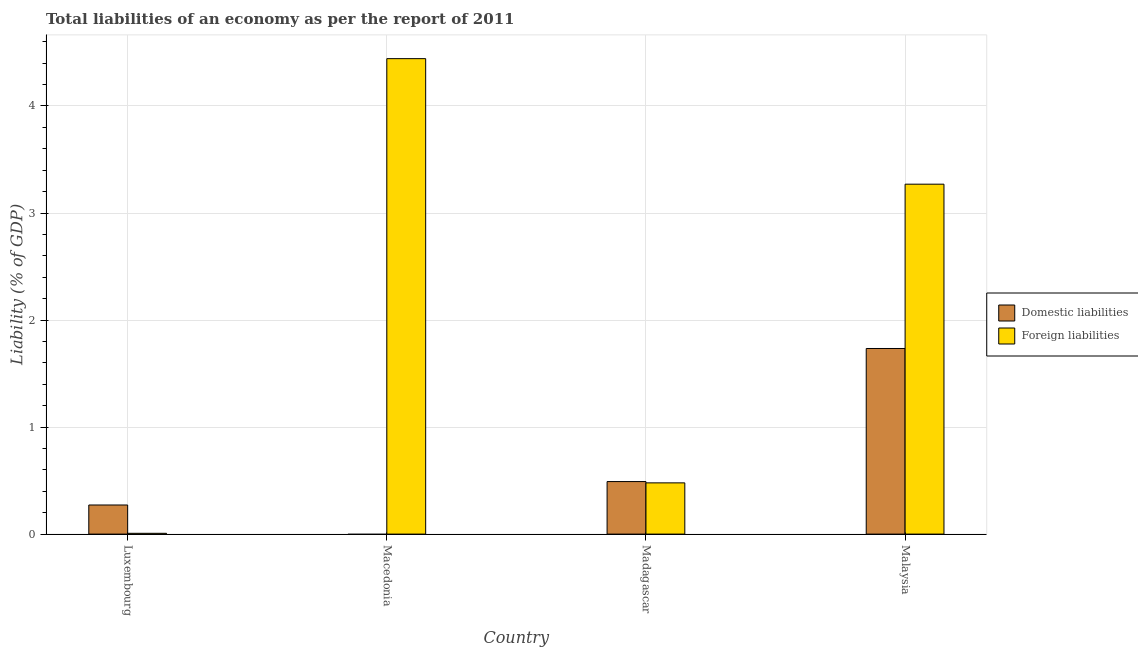How many different coloured bars are there?
Offer a very short reply. 2. Are the number of bars per tick equal to the number of legend labels?
Ensure brevity in your answer.  No. Are the number of bars on each tick of the X-axis equal?
Keep it short and to the point. No. What is the label of the 2nd group of bars from the left?
Make the answer very short. Macedonia. What is the incurrence of foreign liabilities in Macedonia?
Provide a succinct answer. 4.44. Across all countries, what is the maximum incurrence of foreign liabilities?
Provide a succinct answer. 4.44. Across all countries, what is the minimum incurrence of foreign liabilities?
Give a very brief answer. 0.01. In which country was the incurrence of foreign liabilities maximum?
Offer a very short reply. Macedonia. What is the total incurrence of foreign liabilities in the graph?
Your answer should be very brief. 8.2. What is the difference between the incurrence of foreign liabilities in Macedonia and that in Madagascar?
Provide a succinct answer. 3.96. What is the difference between the incurrence of foreign liabilities in Malaysia and the incurrence of domestic liabilities in Luxembourg?
Your answer should be compact. 3. What is the average incurrence of foreign liabilities per country?
Keep it short and to the point. 2.05. What is the difference between the incurrence of domestic liabilities and incurrence of foreign liabilities in Luxembourg?
Make the answer very short. 0.26. What is the ratio of the incurrence of domestic liabilities in Madagascar to that in Malaysia?
Provide a succinct answer. 0.28. Is the incurrence of foreign liabilities in Macedonia less than that in Malaysia?
Make the answer very short. No. Is the difference between the incurrence of foreign liabilities in Luxembourg and Madagascar greater than the difference between the incurrence of domestic liabilities in Luxembourg and Madagascar?
Give a very brief answer. No. What is the difference between the highest and the second highest incurrence of foreign liabilities?
Give a very brief answer. 1.17. What is the difference between the highest and the lowest incurrence of domestic liabilities?
Provide a short and direct response. 1.73. In how many countries, is the incurrence of foreign liabilities greater than the average incurrence of foreign liabilities taken over all countries?
Your answer should be compact. 2. How many bars are there?
Your answer should be very brief. 7. How many countries are there in the graph?
Your answer should be compact. 4. Does the graph contain any zero values?
Make the answer very short. Yes. Does the graph contain grids?
Offer a terse response. Yes. How many legend labels are there?
Offer a very short reply. 2. How are the legend labels stacked?
Ensure brevity in your answer.  Vertical. What is the title of the graph?
Offer a terse response. Total liabilities of an economy as per the report of 2011. What is the label or title of the Y-axis?
Offer a terse response. Liability (% of GDP). What is the Liability (% of GDP) in Domestic liabilities in Luxembourg?
Offer a terse response. 0.27. What is the Liability (% of GDP) of Foreign liabilities in Luxembourg?
Provide a succinct answer. 0.01. What is the Liability (% of GDP) in Domestic liabilities in Macedonia?
Your response must be concise. 0. What is the Liability (% of GDP) in Foreign liabilities in Macedonia?
Keep it short and to the point. 4.44. What is the Liability (% of GDP) of Domestic liabilities in Madagascar?
Make the answer very short. 0.49. What is the Liability (% of GDP) in Foreign liabilities in Madagascar?
Your response must be concise. 0.48. What is the Liability (% of GDP) of Domestic liabilities in Malaysia?
Give a very brief answer. 1.73. What is the Liability (% of GDP) of Foreign liabilities in Malaysia?
Offer a very short reply. 3.27. Across all countries, what is the maximum Liability (% of GDP) of Domestic liabilities?
Ensure brevity in your answer.  1.73. Across all countries, what is the maximum Liability (% of GDP) of Foreign liabilities?
Keep it short and to the point. 4.44. Across all countries, what is the minimum Liability (% of GDP) of Domestic liabilities?
Keep it short and to the point. 0. Across all countries, what is the minimum Liability (% of GDP) of Foreign liabilities?
Your answer should be compact. 0.01. What is the total Liability (% of GDP) of Domestic liabilities in the graph?
Offer a very short reply. 2.5. What is the total Liability (% of GDP) of Foreign liabilities in the graph?
Your response must be concise. 8.2. What is the difference between the Liability (% of GDP) of Foreign liabilities in Luxembourg and that in Macedonia?
Keep it short and to the point. -4.43. What is the difference between the Liability (% of GDP) in Domestic liabilities in Luxembourg and that in Madagascar?
Your response must be concise. -0.22. What is the difference between the Liability (% of GDP) in Foreign liabilities in Luxembourg and that in Madagascar?
Make the answer very short. -0.47. What is the difference between the Liability (% of GDP) in Domestic liabilities in Luxembourg and that in Malaysia?
Make the answer very short. -1.46. What is the difference between the Liability (% of GDP) of Foreign liabilities in Luxembourg and that in Malaysia?
Offer a very short reply. -3.26. What is the difference between the Liability (% of GDP) of Foreign liabilities in Macedonia and that in Madagascar?
Your answer should be compact. 3.96. What is the difference between the Liability (% of GDP) in Foreign liabilities in Macedonia and that in Malaysia?
Ensure brevity in your answer.  1.17. What is the difference between the Liability (% of GDP) of Domestic liabilities in Madagascar and that in Malaysia?
Keep it short and to the point. -1.24. What is the difference between the Liability (% of GDP) of Foreign liabilities in Madagascar and that in Malaysia?
Provide a succinct answer. -2.79. What is the difference between the Liability (% of GDP) of Domestic liabilities in Luxembourg and the Liability (% of GDP) of Foreign liabilities in Macedonia?
Your answer should be very brief. -4.17. What is the difference between the Liability (% of GDP) in Domestic liabilities in Luxembourg and the Liability (% of GDP) in Foreign liabilities in Madagascar?
Your answer should be compact. -0.21. What is the difference between the Liability (% of GDP) in Domestic liabilities in Luxembourg and the Liability (% of GDP) in Foreign liabilities in Malaysia?
Your answer should be compact. -3. What is the difference between the Liability (% of GDP) in Domestic liabilities in Madagascar and the Liability (% of GDP) in Foreign liabilities in Malaysia?
Provide a succinct answer. -2.78. What is the average Liability (% of GDP) in Domestic liabilities per country?
Keep it short and to the point. 0.62. What is the average Liability (% of GDP) of Foreign liabilities per country?
Keep it short and to the point. 2.05. What is the difference between the Liability (% of GDP) in Domestic liabilities and Liability (% of GDP) in Foreign liabilities in Luxembourg?
Your answer should be very brief. 0.26. What is the difference between the Liability (% of GDP) in Domestic liabilities and Liability (% of GDP) in Foreign liabilities in Madagascar?
Offer a terse response. 0.01. What is the difference between the Liability (% of GDP) in Domestic liabilities and Liability (% of GDP) in Foreign liabilities in Malaysia?
Provide a succinct answer. -1.54. What is the ratio of the Liability (% of GDP) of Foreign liabilities in Luxembourg to that in Macedonia?
Your answer should be compact. 0. What is the ratio of the Liability (% of GDP) of Domestic liabilities in Luxembourg to that in Madagascar?
Provide a short and direct response. 0.55. What is the ratio of the Liability (% of GDP) of Foreign liabilities in Luxembourg to that in Madagascar?
Your response must be concise. 0.02. What is the ratio of the Liability (% of GDP) of Domestic liabilities in Luxembourg to that in Malaysia?
Provide a succinct answer. 0.16. What is the ratio of the Liability (% of GDP) in Foreign liabilities in Luxembourg to that in Malaysia?
Ensure brevity in your answer.  0. What is the ratio of the Liability (% of GDP) in Foreign liabilities in Macedonia to that in Madagascar?
Your answer should be compact. 9.28. What is the ratio of the Liability (% of GDP) in Foreign liabilities in Macedonia to that in Malaysia?
Give a very brief answer. 1.36. What is the ratio of the Liability (% of GDP) in Domestic liabilities in Madagascar to that in Malaysia?
Provide a succinct answer. 0.28. What is the ratio of the Liability (% of GDP) of Foreign liabilities in Madagascar to that in Malaysia?
Ensure brevity in your answer.  0.15. What is the difference between the highest and the second highest Liability (% of GDP) of Domestic liabilities?
Provide a short and direct response. 1.24. What is the difference between the highest and the second highest Liability (% of GDP) in Foreign liabilities?
Your answer should be compact. 1.17. What is the difference between the highest and the lowest Liability (% of GDP) of Domestic liabilities?
Give a very brief answer. 1.73. What is the difference between the highest and the lowest Liability (% of GDP) in Foreign liabilities?
Your answer should be compact. 4.43. 